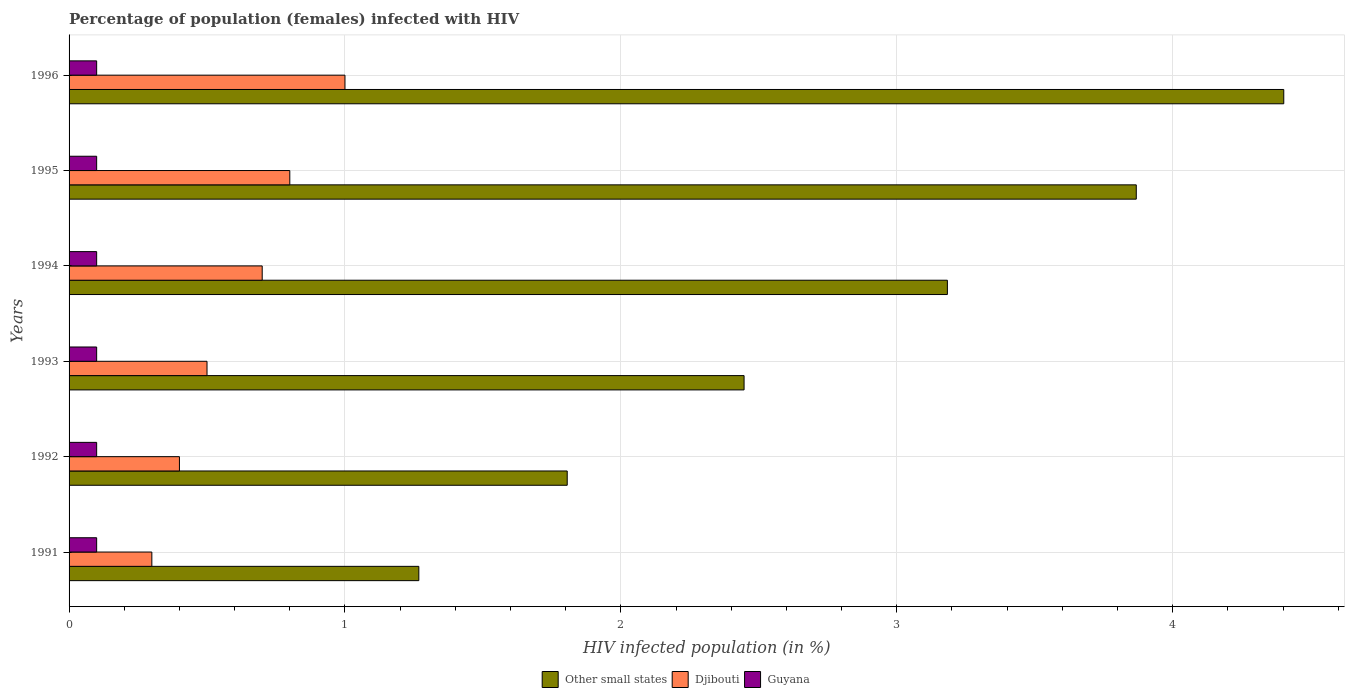How many groups of bars are there?
Offer a very short reply. 6. Are the number of bars per tick equal to the number of legend labels?
Ensure brevity in your answer.  Yes. What is the label of the 3rd group of bars from the top?
Ensure brevity in your answer.  1994. What is the percentage of HIV infected female population in Guyana in 1993?
Your answer should be compact. 0.1. Across all years, what is the maximum percentage of HIV infected female population in Djibouti?
Your answer should be compact. 1. In which year was the percentage of HIV infected female population in Guyana maximum?
Your answer should be very brief. 1991. In which year was the percentage of HIV infected female population in Guyana minimum?
Provide a succinct answer. 1991. What is the total percentage of HIV infected female population in Guyana in the graph?
Provide a short and direct response. 0.6. What is the difference between the percentage of HIV infected female population in Djibouti in 1991 and that in 1996?
Provide a succinct answer. -0.7. What is the difference between the percentage of HIV infected female population in Guyana in 1991 and the percentage of HIV infected female population in Djibouti in 1995?
Make the answer very short. -0.7. What is the average percentage of HIV infected female population in Guyana per year?
Give a very brief answer. 0.1. In the year 1996, what is the difference between the percentage of HIV infected female population in Guyana and percentage of HIV infected female population in Other small states?
Offer a very short reply. -4.3. In how many years, is the percentage of HIV infected female population in Other small states greater than 4.4 %?
Make the answer very short. 1. What is the ratio of the percentage of HIV infected female population in Djibouti in 1991 to that in 1994?
Your response must be concise. 0.43. What is the difference between the highest and the second highest percentage of HIV infected female population in Djibouti?
Offer a very short reply. 0.2. In how many years, is the percentage of HIV infected female population in Guyana greater than the average percentage of HIV infected female population in Guyana taken over all years?
Your answer should be compact. 6. What does the 2nd bar from the top in 1993 represents?
Give a very brief answer. Djibouti. What does the 2nd bar from the bottom in 1993 represents?
Give a very brief answer. Djibouti. What is the difference between two consecutive major ticks on the X-axis?
Offer a terse response. 1. Are the values on the major ticks of X-axis written in scientific E-notation?
Provide a short and direct response. No. Does the graph contain any zero values?
Your response must be concise. No. Does the graph contain grids?
Provide a short and direct response. Yes. Where does the legend appear in the graph?
Your answer should be compact. Bottom center. What is the title of the graph?
Your answer should be very brief. Percentage of population (females) infected with HIV. What is the label or title of the X-axis?
Your answer should be very brief. HIV infected population (in %). What is the label or title of the Y-axis?
Provide a succinct answer. Years. What is the HIV infected population (in %) in Other small states in 1991?
Make the answer very short. 1.27. What is the HIV infected population (in %) of Djibouti in 1991?
Your answer should be compact. 0.3. What is the HIV infected population (in %) of Other small states in 1992?
Offer a terse response. 1.81. What is the HIV infected population (in %) of Djibouti in 1992?
Provide a succinct answer. 0.4. What is the HIV infected population (in %) of Other small states in 1993?
Your response must be concise. 2.45. What is the HIV infected population (in %) of Guyana in 1993?
Your response must be concise. 0.1. What is the HIV infected population (in %) in Other small states in 1994?
Your answer should be very brief. 3.18. What is the HIV infected population (in %) of Djibouti in 1994?
Your answer should be compact. 0.7. What is the HIV infected population (in %) of Guyana in 1994?
Provide a succinct answer. 0.1. What is the HIV infected population (in %) in Other small states in 1995?
Offer a very short reply. 3.87. What is the HIV infected population (in %) in Other small states in 1996?
Provide a short and direct response. 4.4. Across all years, what is the maximum HIV infected population (in %) in Other small states?
Ensure brevity in your answer.  4.4. Across all years, what is the minimum HIV infected population (in %) in Other small states?
Your response must be concise. 1.27. Across all years, what is the minimum HIV infected population (in %) in Djibouti?
Your response must be concise. 0.3. Across all years, what is the minimum HIV infected population (in %) in Guyana?
Provide a succinct answer. 0.1. What is the total HIV infected population (in %) in Other small states in the graph?
Your answer should be compact. 16.97. What is the difference between the HIV infected population (in %) in Other small states in 1991 and that in 1992?
Your answer should be very brief. -0.54. What is the difference between the HIV infected population (in %) in Djibouti in 1991 and that in 1992?
Offer a very short reply. -0.1. What is the difference between the HIV infected population (in %) in Guyana in 1991 and that in 1992?
Give a very brief answer. 0. What is the difference between the HIV infected population (in %) in Other small states in 1991 and that in 1993?
Ensure brevity in your answer.  -1.18. What is the difference between the HIV infected population (in %) in Djibouti in 1991 and that in 1993?
Keep it short and to the point. -0.2. What is the difference between the HIV infected population (in %) in Guyana in 1991 and that in 1993?
Your answer should be compact. 0. What is the difference between the HIV infected population (in %) in Other small states in 1991 and that in 1994?
Make the answer very short. -1.92. What is the difference between the HIV infected population (in %) of Djibouti in 1991 and that in 1994?
Give a very brief answer. -0.4. What is the difference between the HIV infected population (in %) of Other small states in 1991 and that in 1995?
Ensure brevity in your answer.  -2.6. What is the difference between the HIV infected population (in %) of Djibouti in 1991 and that in 1995?
Offer a very short reply. -0.5. What is the difference between the HIV infected population (in %) of Guyana in 1991 and that in 1995?
Offer a very short reply. 0. What is the difference between the HIV infected population (in %) in Other small states in 1991 and that in 1996?
Keep it short and to the point. -3.13. What is the difference between the HIV infected population (in %) in Djibouti in 1991 and that in 1996?
Your answer should be compact. -0.7. What is the difference between the HIV infected population (in %) in Other small states in 1992 and that in 1993?
Make the answer very short. -0.64. What is the difference between the HIV infected population (in %) of Djibouti in 1992 and that in 1993?
Provide a succinct answer. -0.1. What is the difference between the HIV infected population (in %) of Other small states in 1992 and that in 1994?
Offer a terse response. -1.38. What is the difference between the HIV infected population (in %) of Djibouti in 1992 and that in 1994?
Your response must be concise. -0.3. What is the difference between the HIV infected population (in %) of Guyana in 1992 and that in 1994?
Your response must be concise. 0. What is the difference between the HIV infected population (in %) of Other small states in 1992 and that in 1995?
Your response must be concise. -2.06. What is the difference between the HIV infected population (in %) in Other small states in 1992 and that in 1996?
Ensure brevity in your answer.  -2.6. What is the difference between the HIV infected population (in %) in Guyana in 1992 and that in 1996?
Your response must be concise. 0. What is the difference between the HIV infected population (in %) of Other small states in 1993 and that in 1994?
Your response must be concise. -0.74. What is the difference between the HIV infected population (in %) in Guyana in 1993 and that in 1994?
Your answer should be very brief. 0. What is the difference between the HIV infected population (in %) of Other small states in 1993 and that in 1995?
Your answer should be very brief. -1.42. What is the difference between the HIV infected population (in %) of Djibouti in 1993 and that in 1995?
Your answer should be compact. -0.3. What is the difference between the HIV infected population (in %) of Other small states in 1993 and that in 1996?
Your response must be concise. -1.96. What is the difference between the HIV infected population (in %) of Other small states in 1994 and that in 1995?
Your answer should be compact. -0.68. What is the difference between the HIV infected population (in %) in Djibouti in 1994 and that in 1995?
Your answer should be very brief. -0.1. What is the difference between the HIV infected population (in %) in Other small states in 1994 and that in 1996?
Provide a short and direct response. -1.22. What is the difference between the HIV infected population (in %) in Djibouti in 1994 and that in 1996?
Make the answer very short. -0.3. What is the difference between the HIV infected population (in %) of Guyana in 1994 and that in 1996?
Provide a short and direct response. 0. What is the difference between the HIV infected population (in %) of Other small states in 1995 and that in 1996?
Your answer should be very brief. -0.53. What is the difference between the HIV infected population (in %) in Other small states in 1991 and the HIV infected population (in %) in Djibouti in 1992?
Ensure brevity in your answer.  0.87. What is the difference between the HIV infected population (in %) in Other small states in 1991 and the HIV infected population (in %) in Guyana in 1992?
Keep it short and to the point. 1.17. What is the difference between the HIV infected population (in %) of Djibouti in 1991 and the HIV infected population (in %) of Guyana in 1992?
Offer a very short reply. 0.2. What is the difference between the HIV infected population (in %) of Other small states in 1991 and the HIV infected population (in %) of Djibouti in 1993?
Ensure brevity in your answer.  0.77. What is the difference between the HIV infected population (in %) in Other small states in 1991 and the HIV infected population (in %) in Guyana in 1993?
Your answer should be compact. 1.17. What is the difference between the HIV infected population (in %) of Other small states in 1991 and the HIV infected population (in %) of Djibouti in 1994?
Provide a short and direct response. 0.57. What is the difference between the HIV infected population (in %) in Other small states in 1991 and the HIV infected population (in %) in Guyana in 1994?
Offer a terse response. 1.17. What is the difference between the HIV infected population (in %) of Other small states in 1991 and the HIV infected population (in %) of Djibouti in 1995?
Your answer should be very brief. 0.47. What is the difference between the HIV infected population (in %) of Other small states in 1991 and the HIV infected population (in %) of Guyana in 1995?
Give a very brief answer. 1.17. What is the difference between the HIV infected population (in %) in Djibouti in 1991 and the HIV infected population (in %) in Guyana in 1995?
Provide a succinct answer. 0.2. What is the difference between the HIV infected population (in %) of Other small states in 1991 and the HIV infected population (in %) of Djibouti in 1996?
Your answer should be compact. 0.27. What is the difference between the HIV infected population (in %) in Other small states in 1991 and the HIV infected population (in %) in Guyana in 1996?
Ensure brevity in your answer.  1.17. What is the difference between the HIV infected population (in %) in Djibouti in 1991 and the HIV infected population (in %) in Guyana in 1996?
Give a very brief answer. 0.2. What is the difference between the HIV infected population (in %) in Other small states in 1992 and the HIV infected population (in %) in Djibouti in 1993?
Your answer should be compact. 1.31. What is the difference between the HIV infected population (in %) of Other small states in 1992 and the HIV infected population (in %) of Guyana in 1993?
Give a very brief answer. 1.71. What is the difference between the HIV infected population (in %) in Other small states in 1992 and the HIV infected population (in %) in Djibouti in 1994?
Ensure brevity in your answer.  1.11. What is the difference between the HIV infected population (in %) of Other small states in 1992 and the HIV infected population (in %) of Guyana in 1994?
Keep it short and to the point. 1.71. What is the difference between the HIV infected population (in %) of Djibouti in 1992 and the HIV infected population (in %) of Guyana in 1994?
Your answer should be compact. 0.3. What is the difference between the HIV infected population (in %) in Other small states in 1992 and the HIV infected population (in %) in Djibouti in 1995?
Give a very brief answer. 1.01. What is the difference between the HIV infected population (in %) of Other small states in 1992 and the HIV infected population (in %) of Guyana in 1995?
Give a very brief answer. 1.71. What is the difference between the HIV infected population (in %) of Djibouti in 1992 and the HIV infected population (in %) of Guyana in 1995?
Provide a succinct answer. 0.3. What is the difference between the HIV infected population (in %) of Other small states in 1992 and the HIV infected population (in %) of Djibouti in 1996?
Your answer should be compact. 0.81. What is the difference between the HIV infected population (in %) in Other small states in 1992 and the HIV infected population (in %) in Guyana in 1996?
Offer a very short reply. 1.71. What is the difference between the HIV infected population (in %) of Other small states in 1993 and the HIV infected population (in %) of Djibouti in 1994?
Offer a very short reply. 1.75. What is the difference between the HIV infected population (in %) in Other small states in 1993 and the HIV infected population (in %) in Guyana in 1994?
Your response must be concise. 2.35. What is the difference between the HIV infected population (in %) of Other small states in 1993 and the HIV infected population (in %) of Djibouti in 1995?
Your answer should be very brief. 1.65. What is the difference between the HIV infected population (in %) in Other small states in 1993 and the HIV infected population (in %) in Guyana in 1995?
Your answer should be compact. 2.35. What is the difference between the HIV infected population (in %) of Other small states in 1993 and the HIV infected population (in %) of Djibouti in 1996?
Make the answer very short. 1.45. What is the difference between the HIV infected population (in %) of Other small states in 1993 and the HIV infected population (in %) of Guyana in 1996?
Give a very brief answer. 2.35. What is the difference between the HIV infected population (in %) in Djibouti in 1993 and the HIV infected population (in %) in Guyana in 1996?
Give a very brief answer. 0.4. What is the difference between the HIV infected population (in %) in Other small states in 1994 and the HIV infected population (in %) in Djibouti in 1995?
Your answer should be compact. 2.38. What is the difference between the HIV infected population (in %) in Other small states in 1994 and the HIV infected population (in %) in Guyana in 1995?
Offer a very short reply. 3.08. What is the difference between the HIV infected population (in %) in Djibouti in 1994 and the HIV infected population (in %) in Guyana in 1995?
Make the answer very short. 0.6. What is the difference between the HIV infected population (in %) in Other small states in 1994 and the HIV infected population (in %) in Djibouti in 1996?
Your answer should be compact. 2.18. What is the difference between the HIV infected population (in %) in Other small states in 1994 and the HIV infected population (in %) in Guyana in 1996?
Offer a very short reply. 3.08. What is the difference between the HIV infected population (in %) in Djibouti in 1994 and the HIV infected population (in %) in Guyana in 1996?
Keep it short and to the point. 0.6. What is the difference between the HIV infected population (in %) of Other small states in 1995 and the HIV infected population (in %) of Djibouti in 1996?
Offer a very short reply. 2.87. What is the difference between the HIV infected population (in %) in Other small states in 1995 and the HIV infected population (in %) in Guyana in 1996?
Keep it short and to the point. 3.77. What is the difference between the HIV infected population (in %) in Djibouti in 1995 and the HIV infected population (in %) in Guyana in 1996?
Your answer should be very brief. 0.7. What is the average HIV infected population (in %) in Other small states per year?
Ensure brevity in your answer.  2.83. What is the average HIV infected population (in %) of Djibouti per year?
Your response must be concise. 0.62. In the year 1991, what is the difference between the HIV infected population (in %) in Other small states and HIV infected population (in %) in Guyana?
Make the answer very short. 1.17. In the year 1991, what is the difference between the HIV infected population (in %) of Djibouti and HIV infected population (in %) of Guyana?
Offer a very short reply. 0.2. In the year 1992, what is the difference between the HIV infected population (in %) of Other small states and HIV infected population (in %) of Djibouti?
Your response must be concise. 1.41. In the year 1992, what is the difference between the HIV infected population (in %) in Other small states and HIV infected population (in %) in Guyana?
Offer a terse response. 1.71. In the year 1993, what is the difference between the HIV infected population (in %) of Other small states and HIV infected population (in %) of Djibouti?
Your response must be concise. 1.95. In the year 1993, what is the difference between the HIV infected population (in %) in Other small states and HIV infected population (in %) in Guyana?
Keep it short and to the point. 2.35. In the year 1994, what is the difference between the HIV infected population (in %) of Other small states and HIV infected population (in %) of Djibouti?
Make the answer very short. 2.48. In the year 1994, what is the difference between the HIV infected population (in %) of Other small states and HIV infected population (in %) of Guyana?
Offer a very short reply. 3.08. In the year 1995, what is the difference between the HIV infected population (in %) of Other small states and HIV infected population (in %) of Djibouti?
Ensure brevity in your answer.  3.07. In the year 1995, what is the difference between the HIV infected population (in %) in Other small states and HIV infected population (in %) in Guyana?
Make the answer very short. 3.77. In the year 1995, what is the difference between the HIV infected population (in %) of Djibouti and HIV infected population (in %) of Guyana?
Offer a terse response. 0.7. In the year 1996, what is the difference between the HIV infected population (in %) in Other small states and HIV infected population (in %) in Djibouti?
Ensure brevity in your answer.  3.4. In the year 1996, what is the difference between the HIV infected population (in %) in Other small states and HIV infected population (in %) in Guyana?
Keep it short and to the point. 4.3. What is the ratio of the HIV infected population (in %) in Other small states in 1991 to that in 1992?
Provide a succinct answer. 0.7. What is the ratio of the HIV infected population (in %) of Djibouti in 1991 to that in 1992?
Your answer should be very brief. 0.75. What is the ratio of the HIV infected population (in %) in Guyana in 1991 to that in 1992?
Provide a short and direct response. 1. What is the ratio of the HIV infected population (in %) in Other small states in 1991 to that in 1993?
Offer a very short reply. 0.52. What is the ratio of the HIV infected population (in %) of Guyana in 1991 to that in 1993?
Provide a succinct answer. 1. What is the ratio of the HIV infected population (in %) of Other small states in 1991 to that in 1994?
Provide a short and direct response. 0.4. What is the ratio of the HIV infected population (in %) in Djibouti in 1991 to that in 1994?
Give a very brief answer. 0.43. What is the ratio of the HIV infected population (in %) in Other small states in 1991 to that in 1995?
Your answer should be very brief. 0.33. What is the ratio of the HIV infected population (in %) of Djibouti in 1991 to that in 1995?
Ensure brevity in your answer.  0.38. What is the ratio of the HIV infected population (in %) of Other small states in 1991 to that in 1996?
Offer a terse response. 0.29. What is the ratio of the HIV infected population (in %) of Djibouti in 1991 to that in 1996?
Give a very brief answer. 0.3. What is the ratio of the HIV infected population (in %) of Guyana in 1991 to that in 1996?
Make the answer very short. 1. What is the ratio of the HIV infected population (in %) of Other small states in 1992 to that in 1993?
Offer a terse response. 0.74. What is the ratio of the HIV infected population (in %) of Other small states in 1992 to that in 1994?
Give a very brief answer. 0.57. What is the ratio of the HIV infected population (in %) in Djibouti in 1992 to that in 1994?
Provide a short and direct response. 0.57. What is the ratio of the HIV infected population (in %) of Guyana in 1992 to that in 1994?
Offer a very short reply. 1. What is the ratio of the HIV infected population (in %) of Other small states in 1992 to that in 1995?
Provide a succinct answer. 0.47. What is the ratio of the HIV infected population (in %) in Djibouti in 1992 to that in 1995?
Make the answer very short. 0.5. What is the ratio of the HIV infected population (in %) in Other small states in 1992 to that in 1996?
Offer a very short reply. 0.41. What is the ratio of the HIV infected population (in %) of Guyana in 1992 to that in 1996?
Provide a succinct answer. 1. What is the ratio of the HIV infected population (in %) in Other small states in 1993 to that in 1994?
Offer a very short reply. 0.77. What is the ratio of the HIV infected population (in %) in Guyana in 1993 to that in 1994?
Provide a short and direct response. 1. What is the ratio of the HIV infected population (in %) of Other small states in 1993 to that in 1995?
Ensure brevity in your answer.  0.63. What is the ratio of the HIV infected population (in %) in Djibouti in 1993 to that in 1995?
Keep it short and to the point. 0.62. What is the ratio of the HIV infected population (in %) in Guyana in 1993 to that in 1995?
Your answer should be compact. 1. What is the ratio of the HIV infected population (in %) in Other small states in 1993 to that in 1996?
Make the answer very short. 0.56. What is the ratio of the HIV infected population (in %) of Guyana in 1993 to that in 1996?
Provide a short and direct response. 1. What is the ratio of the HIV infected population (in %) in Other small states in 1994 to that in 1995?
Give a very brief answer. 0.82. What is the ratio of the HIV infected population (in %) in Djibouti in 1994 to that in 1995?
Provide a succinct answer. 0.88. What is the ratio of the HIV infected population (in %) of Guyana in 1994 to that in 1995?
Provide a short and direct response. 1. What is the ratio of the HIV infected population (in %) in Other small states in 1994 to that in 1996?
Your answer should be compact. 0.72. What is the ratio of the HIV infected population (in %) in Guyana in 1994 to that in 1996?
Offer a terse response. 1. What is the ratio of the HIV infected population (in %) in Other small states in 1995 to that in 1996?
Your answer should be compact. 0.88. What is the ratio of the HIV infected population (in %) in Guyana in 1995 to that in 1996?
Make the answer very short. 1. What is the difference between the highest and the second highest HIV infected population (in %) of Other small states?
Provide a short and direct response. 0.53. What is the difference between the highest and the second highest HIV infected population (in %) of Guyana?
Provide a short and direct response. 0. What is the difference between the highest and the lowest HIV infected population (in %) of Other small states?
Provide a short and direct response. 3.13. What is the difference between the highest and the lowest HIV infected population (in %) of Guyana?
Make the answer very short. 0. 